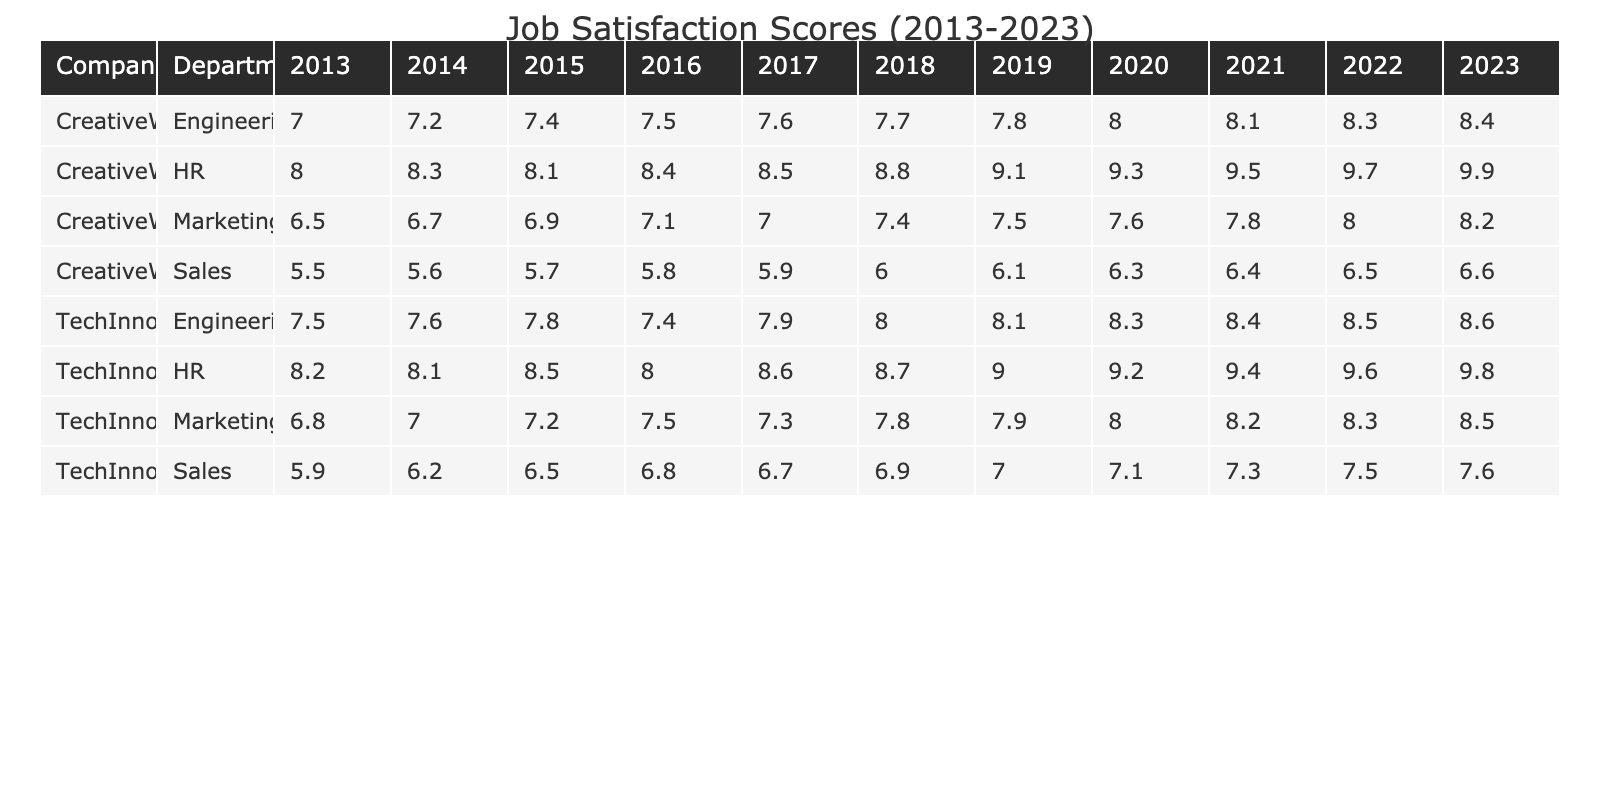What was the job satisfaction score for the TechInnovate HR department in 2023? The job satisfaction score for TechInnovate HR in 2023 is listed in the table under the year 2023 for that department. Looking at the table, it shows a score of 9.8.
Answer: 9.8 What was the highest job satisfaction score recorded in CreativeWorks during the decade? To find the highest score for CreativeWorks, we can look through the scores for all years in that company. Scanning through the table, the highest score appears to be 9.9 in 2023.
Answer: 9.9 What is the difference in job satisfaction scores for the Sales department at TechInnovate between 2013 and 2023? The score for TechInnovate Sales in 2013 is 5.9, and in 2023 it is 7.6. The difference is calculated as 7.6 - 5.9 = 1.7.
Answer: 1.7 Did the job satisfaction score for the Engineering department at CreativeWorks increase every year? To determine if the score increased every year, we need to compare the scores year by year. Checking the table, the scores are 7.0 (2013), 7.2 (2014), 7.4 (2015), 7.5 (2016), 7.6 (2017), 7.7 (2018), 7.8 (2019), 8.0 (2020), 8.1 (2021), 8.3 (2022), and 8.4 (2023). There is a consistent increase.
Answer: Yes What was the average job satisfaction score for the Engineering department at TechInnovate over the decade? To calculate the average, we first need to gather the Engineering scores for TechInnovate from each year, which are: 7.5, 7.6, 7.8, 7.4, 7.9, 8.0, 8.1, 8.3, 8.4, and 8.6. Summing these gives 79.4. Dividing by the number of years (10) gives an average of 7.94.
Answer: 7.94 Which company had a job satisfaction score greater than 8 for the HR department in 2022? Looking at the HR department for both companies in 2022, TechInnovate scored 9.6 and CreativeWorks scored 9.7. Both scores are greater than 8.
Answer: Yes What was the trend in Job Satisfaction Scores for Marketing at CreativeWorks from 2013 to 2023? To see the trend in the Marketing scores at CreativeWorks, we look at the scores for each year: 6.5 (2013), 6.7 (2014), 6.9 (2015), 7.1 (2016), 7.0 (2017), 7.4 (2018), 7.5 (2019), 7.6 (2020), 7.8 (2021), 8.0 (2022), 8.2 (2023). The scores show an overall upward trend with a slight drop in 2017.
Answer: Overall increase with one drop What was the average job satisfaction score for both companies in the Sales department in 2022? For TechInnovate, the Sales score is 7.5 and for CreativeWorks, it's 6.5 in 2022. The average is calculated as (7.5 + 6.5) / 2 = 7.0.
Answer: 7.0 Has the job satisfaction score for HR at TechInnovate reached 9 or higher in the last three years of the analyzed period? Checking the HR scores for TechInnovate in 2021 (9.4), 2022 (9.6), and 2023 (9.8), all are 9 or higher.
Answer: Yes What can be said about the job satisfaction scores for the Marketing department at TechInnovate between 2013 and 2023? The Marketing scores for TechInnovate from 2013 (6.8) to 2023 (8.5) indicate a consistent increase each year when comparing each adjacent year.
Answer: Consistent increase every year 